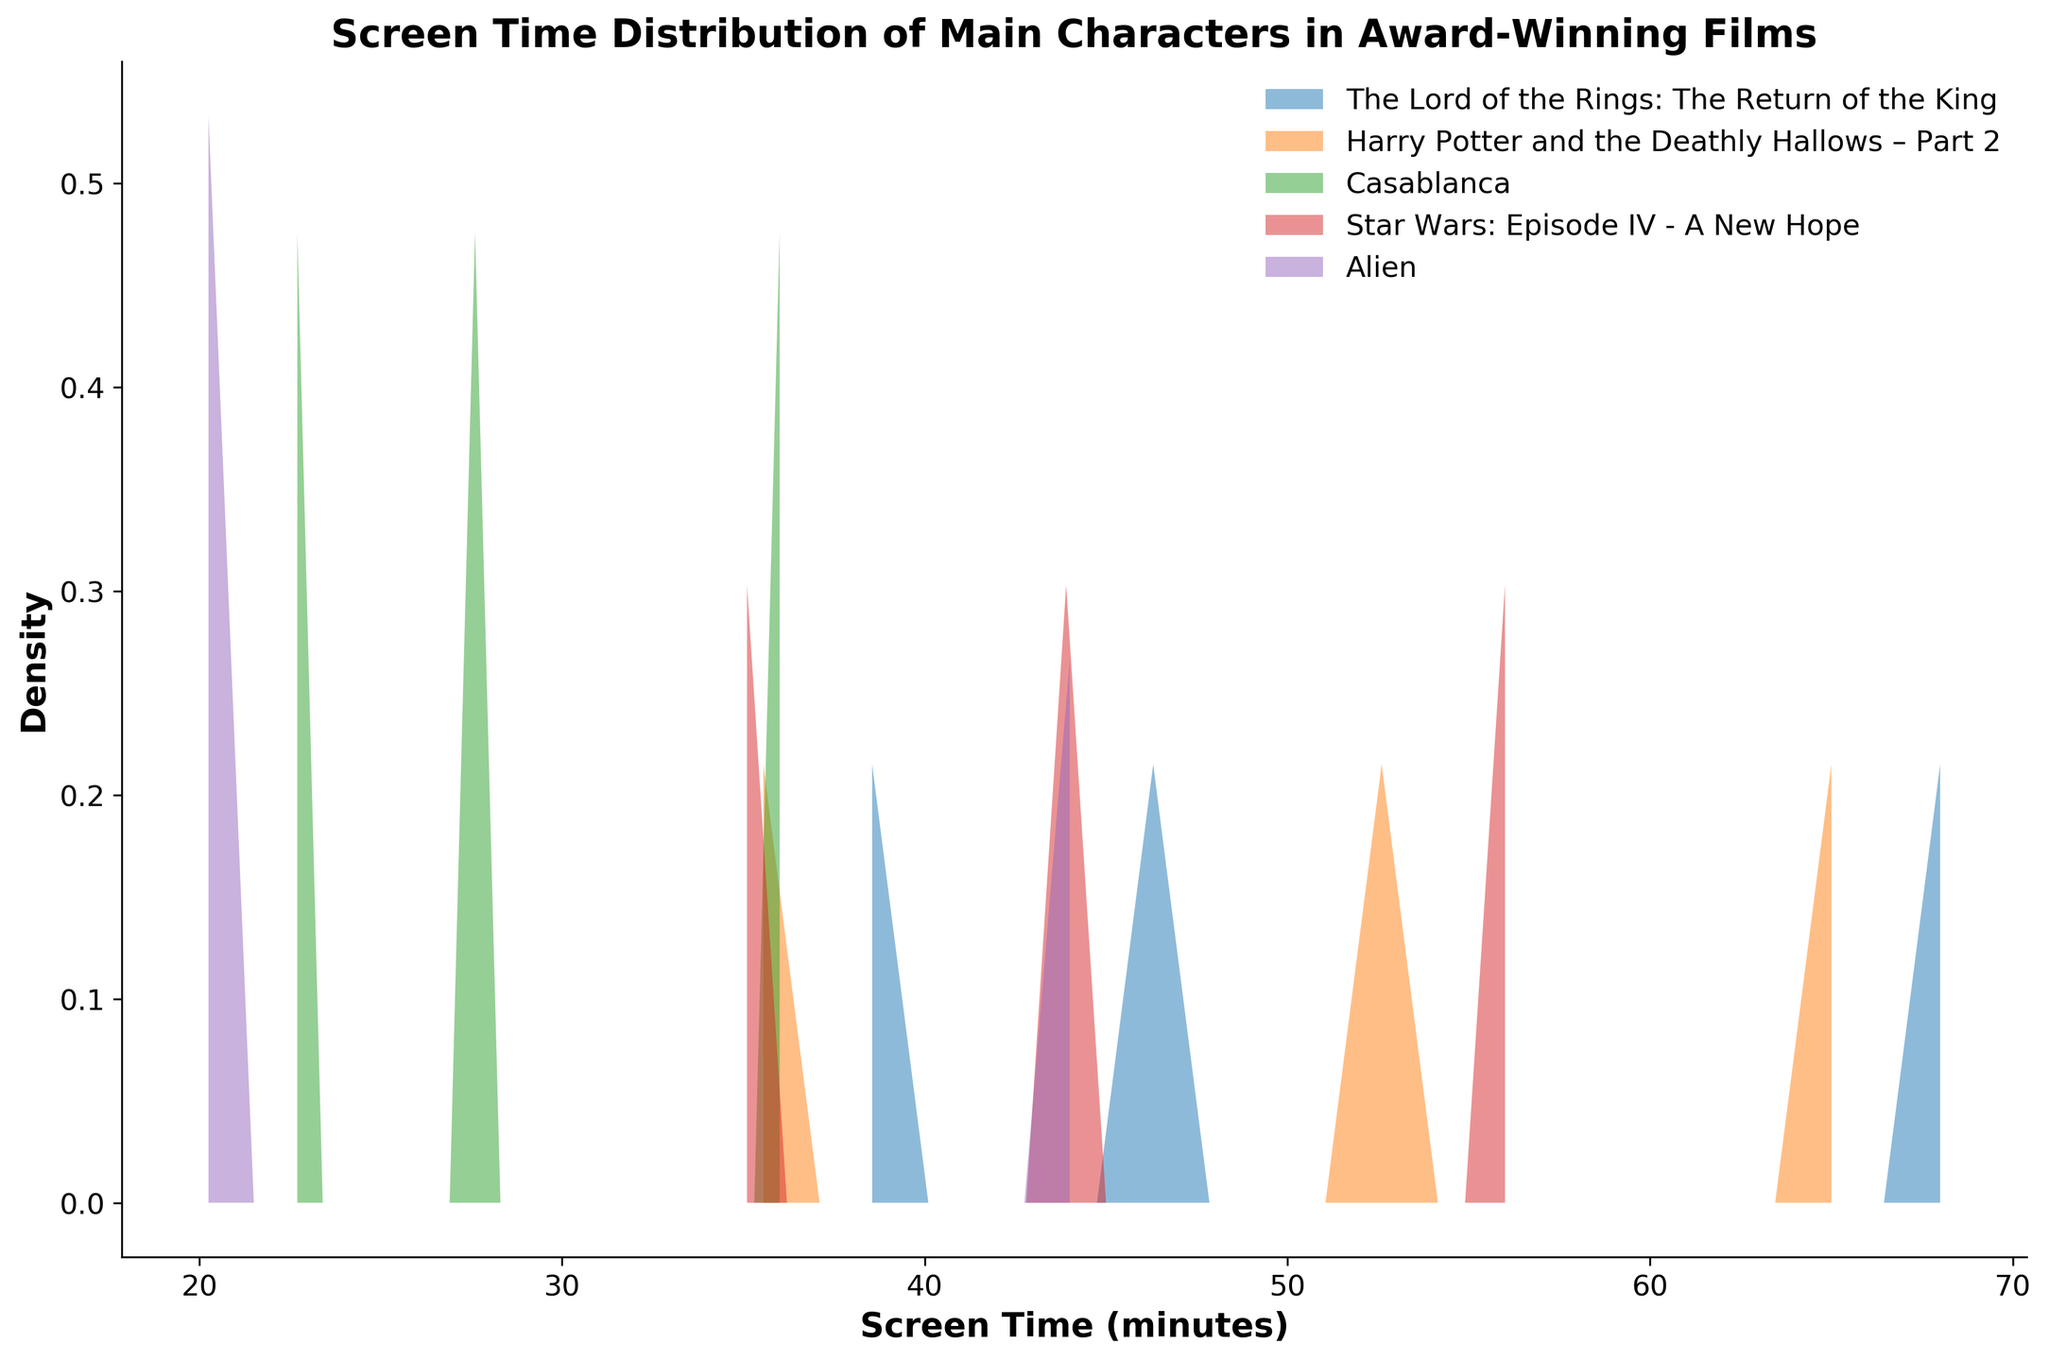How many films are represented in the density plot? There are multiple distinct fill colors in the plot, each representing a different film. By counting the unique fill colors, we can determine the number of films.
Answer: 4 What is the title of the figure? The title is displayed at the top center of the plot with a larger and bolded font.
Answer: Screen Time Distribution of Main Characters in Award-Winning Films What is the range of screen time values displayed on the x-axis? The x-axis spans from the minimum to the maximum screen time values, with labeled tick marks indicating the range.
Answer: 0 to 80 minutes Which film has the highest density peak, and around what screen time does it occur? By observing the peaks of the density curves for each film, we identify the highest one and note the corresponding screen time on the x-axis where it peaks.
Answer: The Lord of the Rings: The Return of the King, around 70 minutes Which film has the smallest spread of screen times among its main characters? The spread of screen times can be assessed by examining the width of the density curves. Narrower curves indicate a smaller spread.
Answer: Alien How do the density peaks of Harry Potter and the Deathly Hallows – Part 2 and Star Wars: Episode IV - A New Hope compare? We compare the height and location of the density peaks of the two films. The one with a higher peak indicates a more concentrated screen time around that value.
Answer: Harry Potter and the Deathly Hallows – Part 2 has a higher peak around 65 minutes, while Star Wars: Episode IV - A New Hope peaks lower around 55 minutes Which film has a density covering the broadest range of screen times? By observing which density curve spans the widest interval on the x-axis, we can determine the film with the broadest range.
Answer: Casablanca What is the median screen time of the main characters in The Lord of the Rings: The Return of the King? To find the median screen time for The Lord of the Rings, we would look for the middlemost value in its distribution curve. Approximate the median by finding the value where half the area under the curve is to the left and half to the right.
Answer: Approximately 45 minutes Between Rick Blaine from Casablanca and Ash from Alien, who has a shorter screen time, and by how much? We look at the specific points on the x-axis corresponding to the screen times of Rick Blaine and Ash. Then, we calculate the difference.
Answer: Ash has a shorter screen time by 14 minutes How evenly are the screen times distributed for the main characters in Harry Potter and the Deathly Hallows – Part 2? Observe the smoothness and spread of the density curve for Harry Potter. A more uniform, less peaked curve suggests a more even distribution of screen times.
Answer: Fairly well distributed 